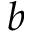<formula> <loc_0><loc_0><loc_500><loc_500>b</formula> 